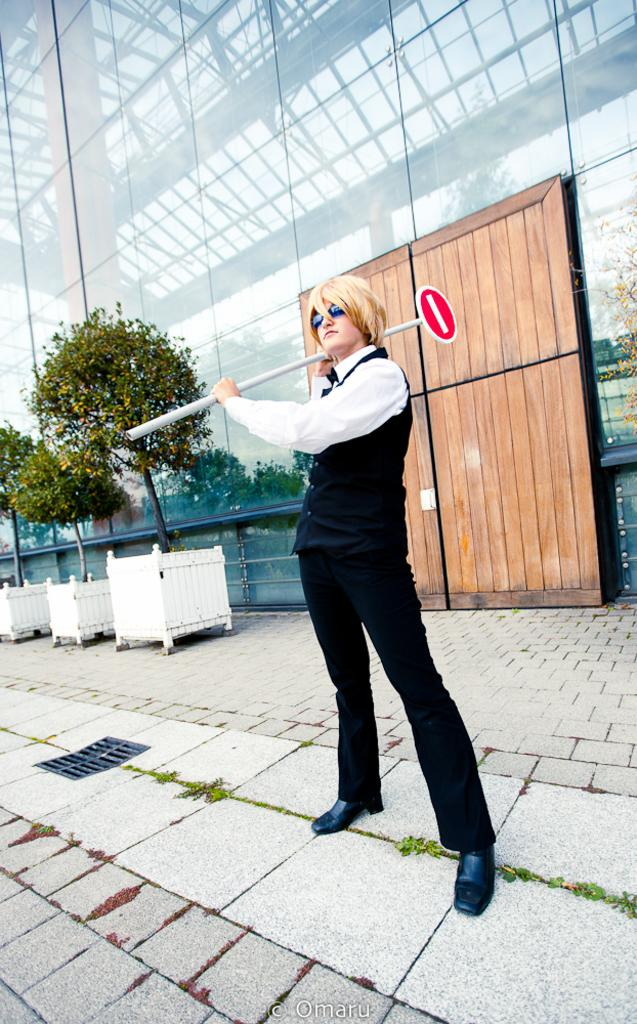What is the main subject of the image? There is a person standing in the center of the image. What is the person holding in the image? The person is holding a sign board. What can be seen in the background of the image? There is a glass building, a wooden object, plant wood pots, and plants in the background of the image. What type of fuel is being used by the person in the image? There is no indication of any fuel being used in the image; the person is simply holding a sign board. Can you tell me how many moms are present in the image? There is no mention of any moms in the image; it features a person holding a sign board and a background with various objects and plants. 